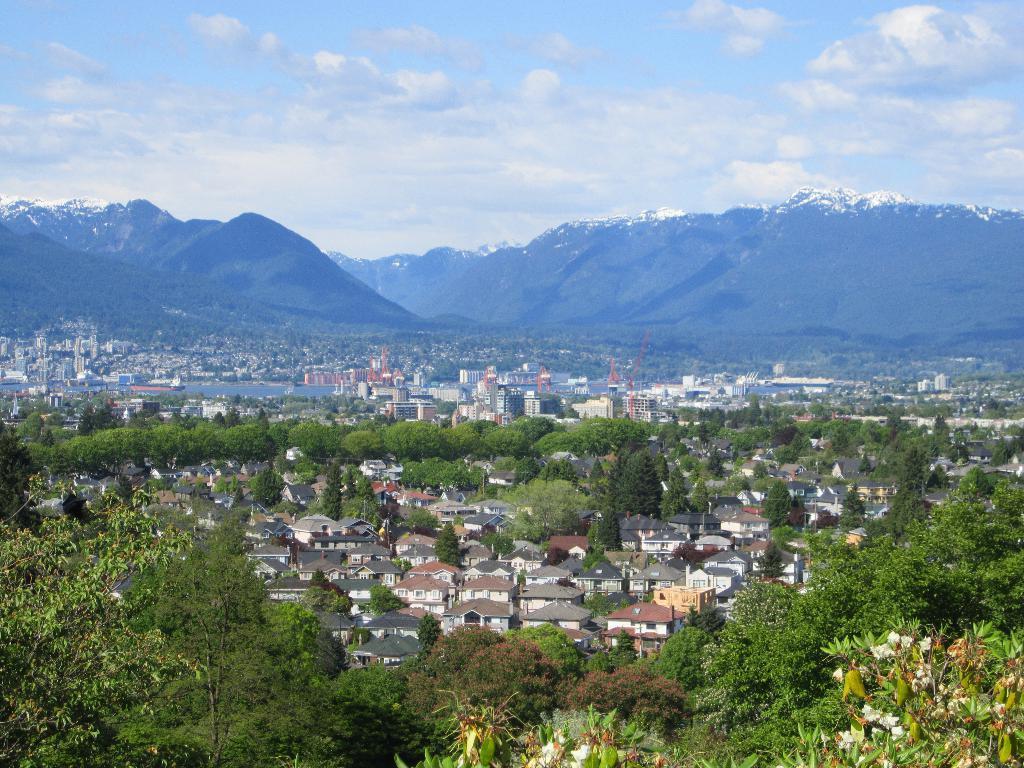In one or two sentences, can you explain what this image depicts? In this picture I can see there are few buildings and there are trees around the building. There are few flowers at the bottom of the image and there are mountains in the backdrop and they are covered with trees and the sky is clear. 